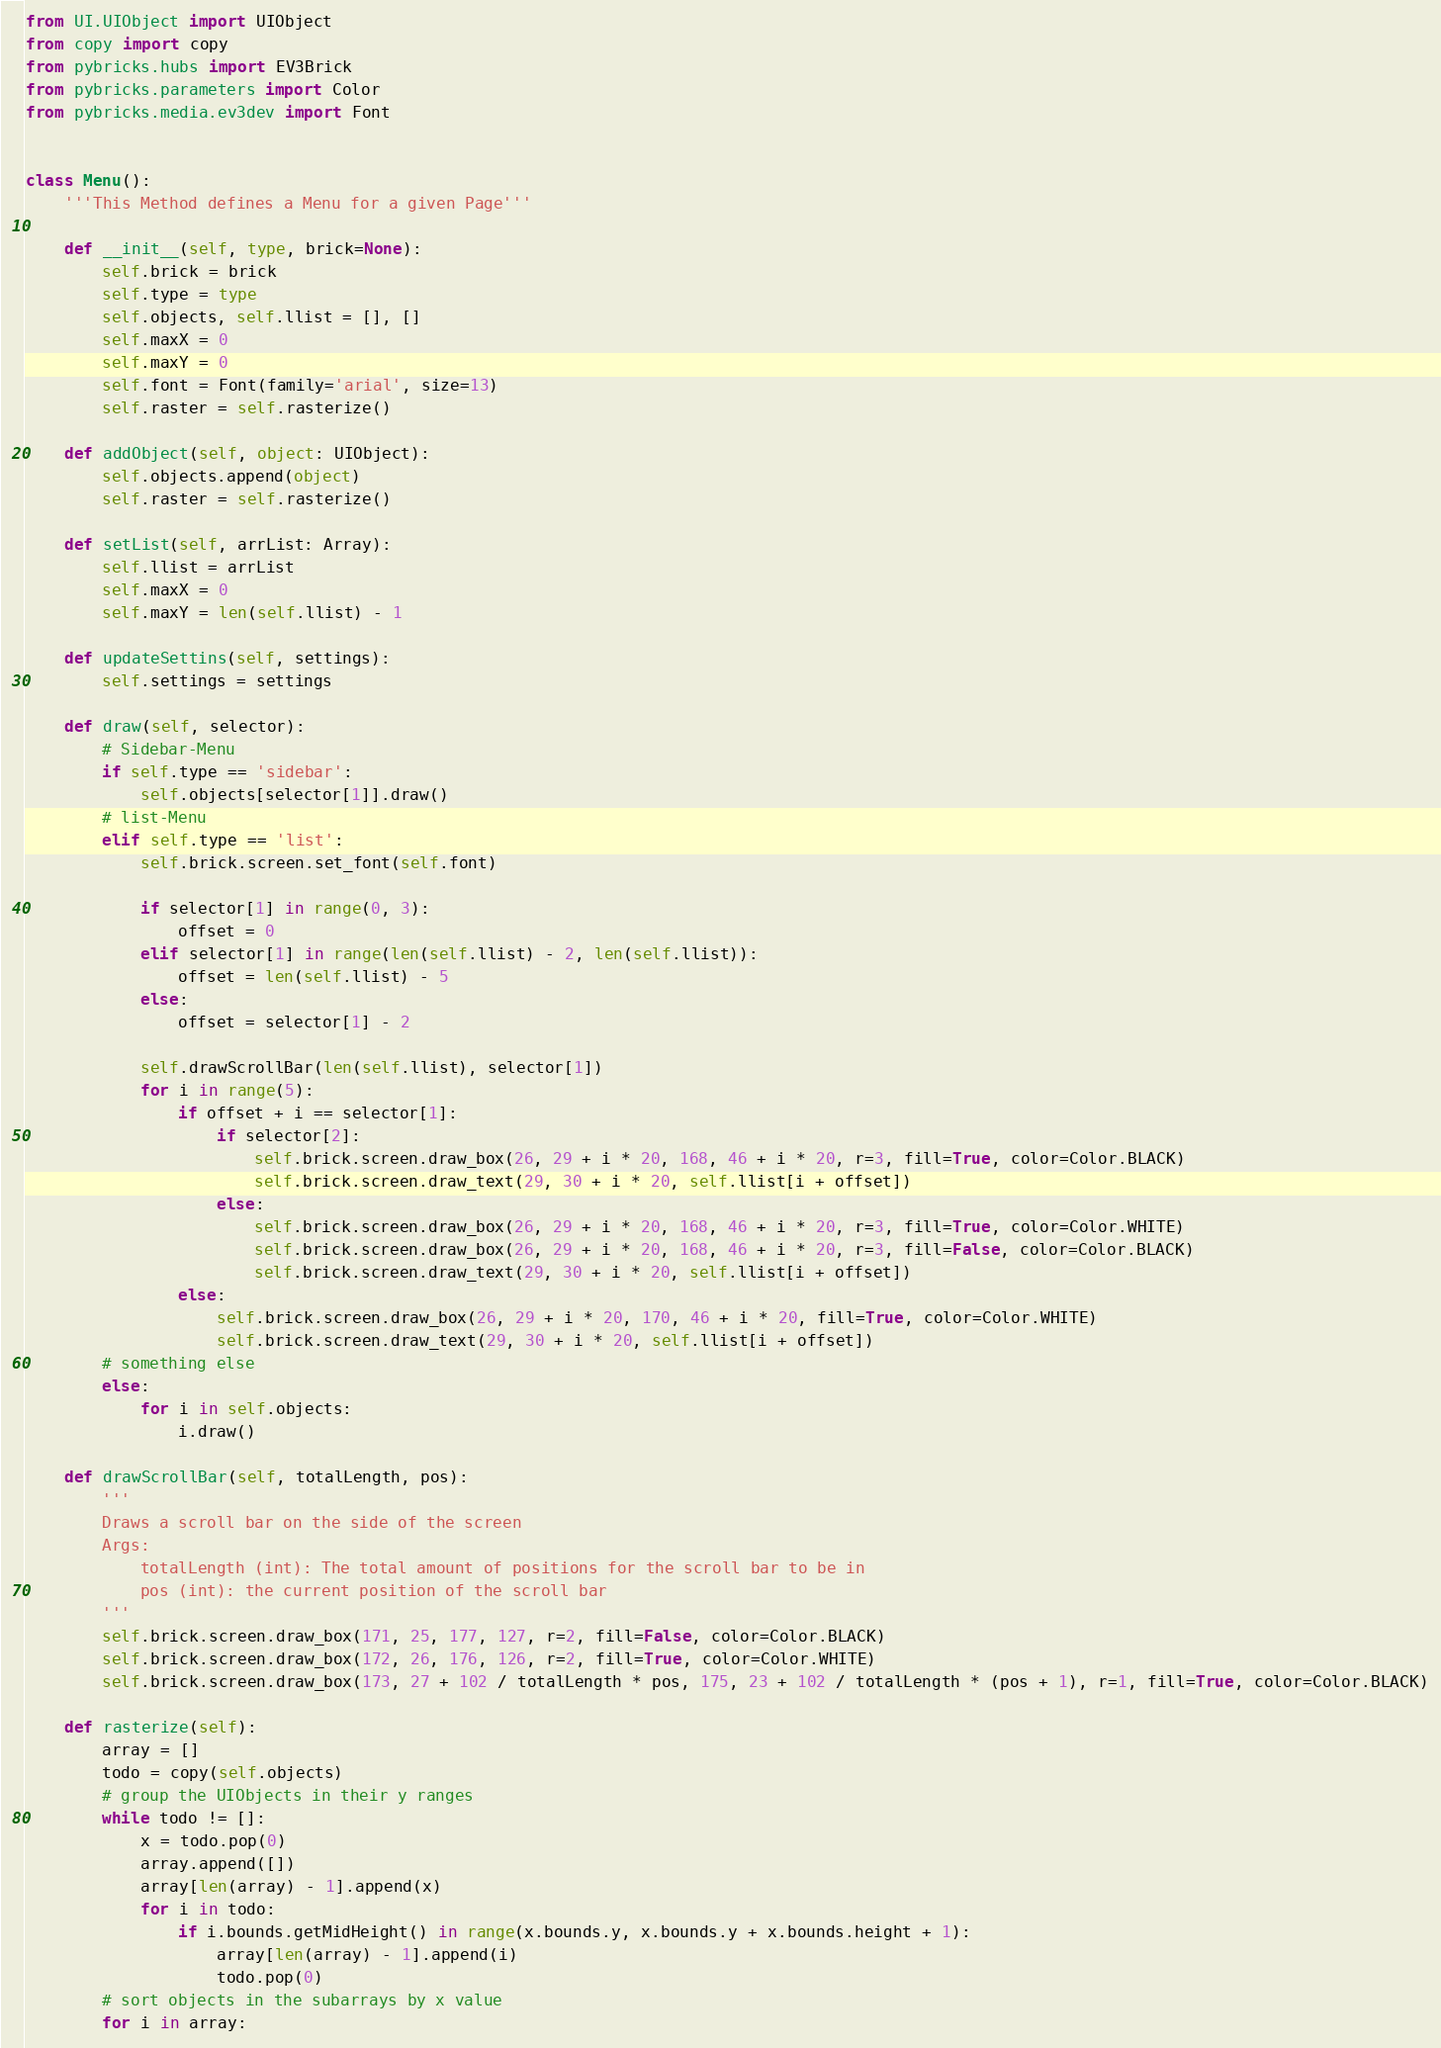Convert code to text. <code><loc_0><loc_0><loc_500><loc_500><_Python_>from UI.UIObject import UIObject
from copy import copy
from pybricks.hubs import EV3Brick
from pybricks.parameters import Color
from pybricks.media.ev3dev import Font


class Menu():
    '''This Method defines a Menu for a given Page'''

    def __init__(self, type, brick=None):
        self.brick = brick
        self.type = type
        self.objects, self.llist = [], []
        self.maxX = 0
        self.maxY = 0
        self.font = Font(family='arial', size=13)
        self.raster = self.rasterize()

    def addObject(self, object: UIObject):
        self.objects.append(object)
        self.raster = self.rasterize()

    def setList(self, arrList: Array):
        self.llist = arrList
        self.maxX = 0
        self.maxY = len(self.llist) - 1

    def updateSettins(self, settings):
        self.settings = settings

    def draw(self, selector):
        # Sidebar-Menu
        if self.type == 'sidebar':
            self.objects[selector[1]].draw()
        # list-Menu
        elif self.type == 'list':
            self.brick.screen.set_font(self.font)

            if selector[1] in range(0, 3):
                offset = 0
            elif selector[1] in range(len(self.llist) - 2, len(self.llist)):
                offset = len(self.llist) - 5
            else:
                offset = selector[1] - 2

            self.drawScrollBar(len(self.llist), selector[1])
            for i in range(5):
                if offset + i == selector[1]:
                    if selector[2]:
                        self.brick.screen.draw_box(26, 29 + i * 20, 168, 46 + i * 20, r=3, fill=True, color=Color.BLACK)
                        self.brick.screen.draw_text(29, 30 + i * 20, self.llist[i + offset])
                    else:
                        self.brick.screen.draw_box(26, 29 + i * 20, 168, 46 + i * 20, r=3, fill=True, color=Color.WHITE)
                        self.brick.screen.draw_box(26, 29 + i * 20, 168, 46 + i * 20, r=3, fill=False, color=Color.BLACK)
                        self.brick.screen.draw_text(29, 30 + i * 20, self.llist[i + offset])
                else:
                    self.brick.screen.draw_box(26, 29 + i * 20, 170, 46 + i * 20, fill=True, color=Color.WHITE)
                    self.brick.screen.draw_text(29, 30 + i * 20, self.llist[i + offset])
        # something else
        else:
            for i in self.objects:
                i.draw()

    def drawScrollBar(self, totalLength, pos):
        '''
        Draws a scroll bar on the side of the screen
        Args:
            totalLength (int): The total amount of positions for the scroll bar to be in
            pos (int): the current position of the scroll bar
        '''
        self.brick.screen.draw_box(171, 25, 177, 127, r=2, fill=False, color=Color.BLACK)
        self.brick.screen.draw_box(172, 26, 176, 126, r=2, fill=True, color=Color.WHITE)
        self.brick.screen.draw_box(173, 27 + 102 / totalLength * pos, 175, 23 + 102 / totalLength * (pos + 1), r=1, fill=True, color=Color.BLACK)

    def rasterize(self):
        array = []
        todo = copy(self.objects)
        # group the UIObjects in their y ranges
        while todo != []:
            x = todo.pop(0)
            array.append([])
            array[len(array) - 1].append(x)
            for i in todo:
                if i.bounds.getMidHeight() in range(x.bounds.y, x.bounds.y + x.bounds.height + 1):
                    array[len(array) - 1].append(i)
                    todo.pop(0)
        # sort objects in the subarrays by x value
        for i in array:</code> 